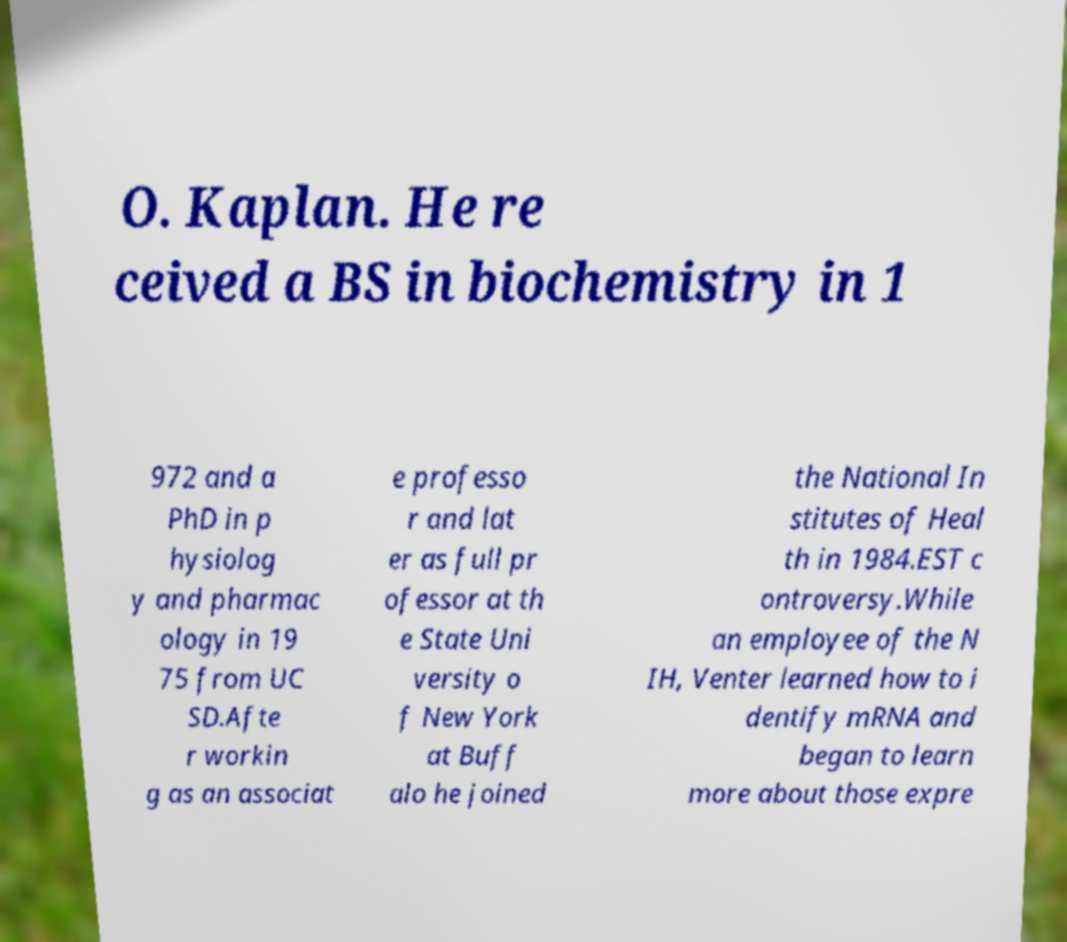What messages or text are displayed in this image? I need them in a readable, typed format. O. Kaplan. He re ceived a BS in biochemistry in 1 972 and a PhD in p hysiolog y and pharmac ology in 19 75 from UC SD.Afte r workin g as an associat e professo r and lat er as full pr ofessor at th e State Uni versity o f New York at Buff alo he joined the National In stitutes of Heal th in 1984.EST c ontroversy.While an employee of the N IH, Venter learned how to i dentify mRNA and began to learn more about those expre 